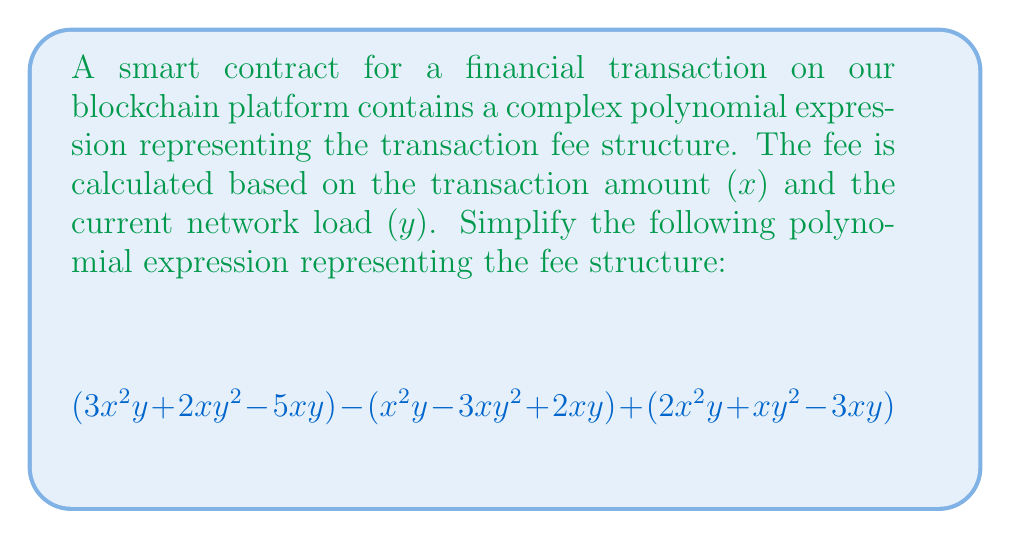What is the answer to this math problem? Let's simplify this polynomial expression step by step:

1) First, let's group like terms:

   $$(3x^2y + 2xy^2 - 5xy) - (x^2y - 3xy^2 + 2xy) + (2x^2y + xy^2 - 3xy)$$

2) Now, let's distribute the negative sign to the second parenthesis:

   $$(3x^2y + 2xy^2 - 5xy) + (-x^2y + 3xy^2 - 2xy) + (2x^2y + xy^2 - 3xy)$$

3) Let's combine like terms:

   For $x^2y$ terms: $3x^2y + (-x^2y) + 2x^2y = 4x^2y$
   
   For $xy^2$ terms: $2xy^2 + 3xy^2 + xy^2 = 6xy^2$
   
   For $xy$ terms: $-5xy + (-2xy) + (-3xy) = -10xy$

4) Now we can write our simplified expression:

   $$4x^2y + 6xy^2 - 10xy$$

5) We can factor out the greatest common factor:

   $$2xy(2x + 3y - 5)$$

This is the most simplified form of the polynomial expression.
Answer: $2xy(2x + 3y - 5)$ 